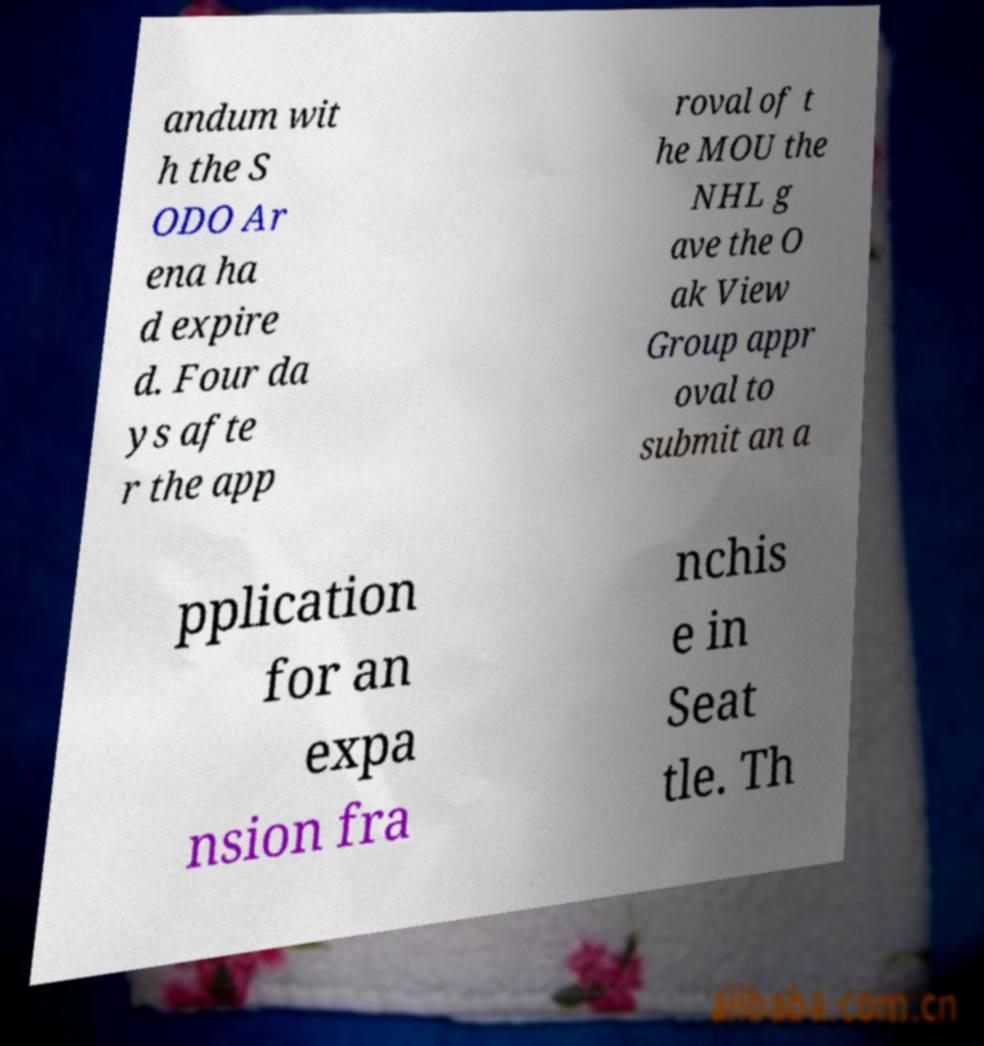Can you read and provide the text displayed in the image?This photo seems to have some interesting text. Can you extract and type it out for me? andum wit h the S ODO Ar ena ha d expire d. Four da ys afte r the app roval of t he MOU the NHL g ave the O ak View Group appr oval to submit an a pplication for an expa nsion fra nchis e in Seat tle. Th 